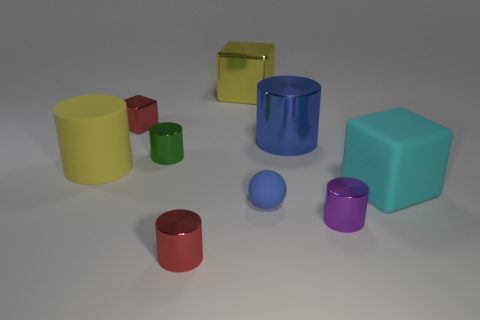There is a object that is the same color as the big matte cylinder; what shape is it?
Provide a short and direct response. Cube. Is the color of the small matte thing the same as the big cylinder that is on the right side of the big yellow cylinder?
Keep it short and to the point. Yes. The shiny cylinder that is the same color as the tiny cube is what size?
Give a very brief answer. Small. There is a large thing that is to the left of the small purple cylinder and in front of the big blue thing; what shape is it?
Provide a short and direct response. Cylinder. There is a blue metal cylinder; are there any small metallic cylinders to the left of it?
Ensure brevity in your answer.  Yes. What is the size of the purple thing that is the same shape as the tiny green object?
Ensure brevity in your answer.  Small. Is the large yellow shiny thing the same shape as the large cyan thing?
Provide a short and direct response. Yes. There is a yellow object on the left side of the big yellow shiny thing that is to the left of the cyan rubber thing; what is its size?
Make the answer very short. Large. What is the color of the large metal thing that is the same shape as the tiny green object?
Keep it short and to the point. Blue. How many large shiny cylinders are the same color as the rubber ball?
Give a very brief answer. 1. 